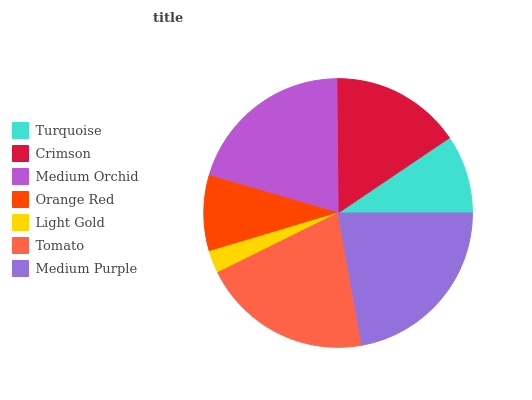Is Light Gold the minimum?
Answer yes or no. Yes. Is Medium Purple the maximum?
Answer yes or no. Yes. Is Crimson the minimum?
Answer yes or no. No. Is Crimson the maximum?
Answer yes or no. No. Is Crimson greater than Turquoise?
Answer yes or no. Yes. Is Turquoise less than Crimson?
Answer yes or no. Yes. Is Turquoise greater than Crimson?
Answer yes or no. No. Is Crimson less than Turquoise?
Answer yes or no. No. Is Crimson the high median?
Answer yes or no. Yes. Is Crimson the low median?
Answer yes or no. Yes. Is Medium Orchid the high median?
Answer yes or no. No. Is Medium Purple the low median?
Answer yes or no. No. 